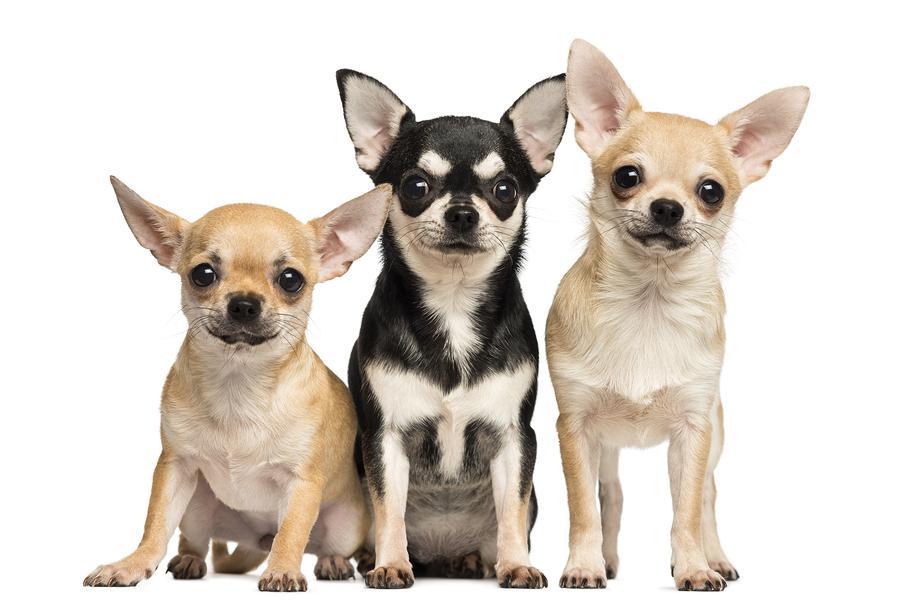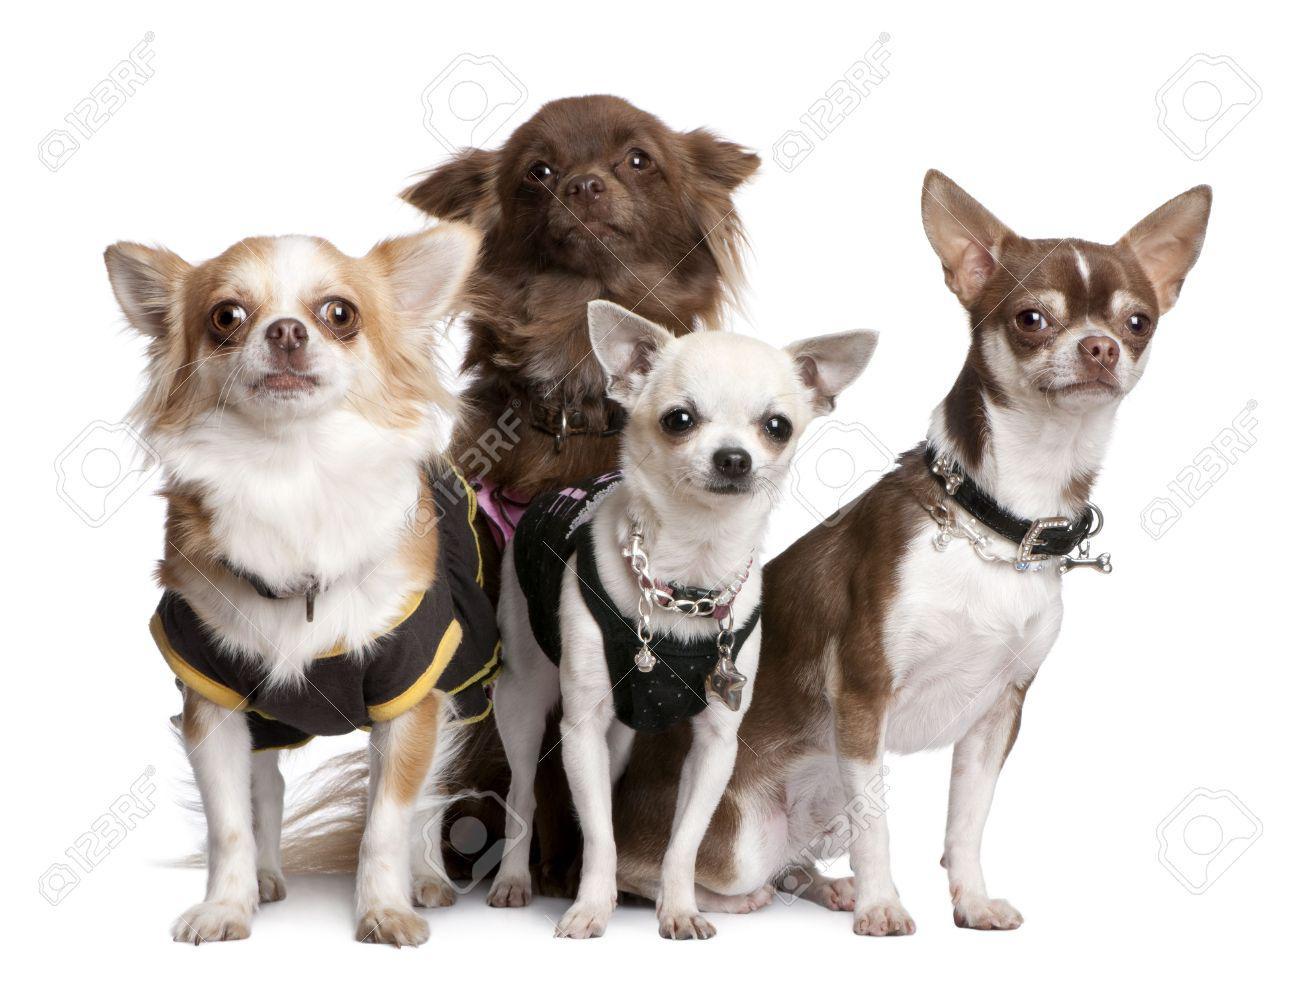The first image is the image on the left, the second image is the image on the right. Analyze the images presented: Is the assertion "One image contains three small dogs, and the other image contains four small dogs." valid? Answer yes or no. Yes. The first image is the image on the left, the second image is the image on the right. Given the left and right images, does the statement "There are more dogs in the image on the right." hold true? Answer yes or no. Yes. 